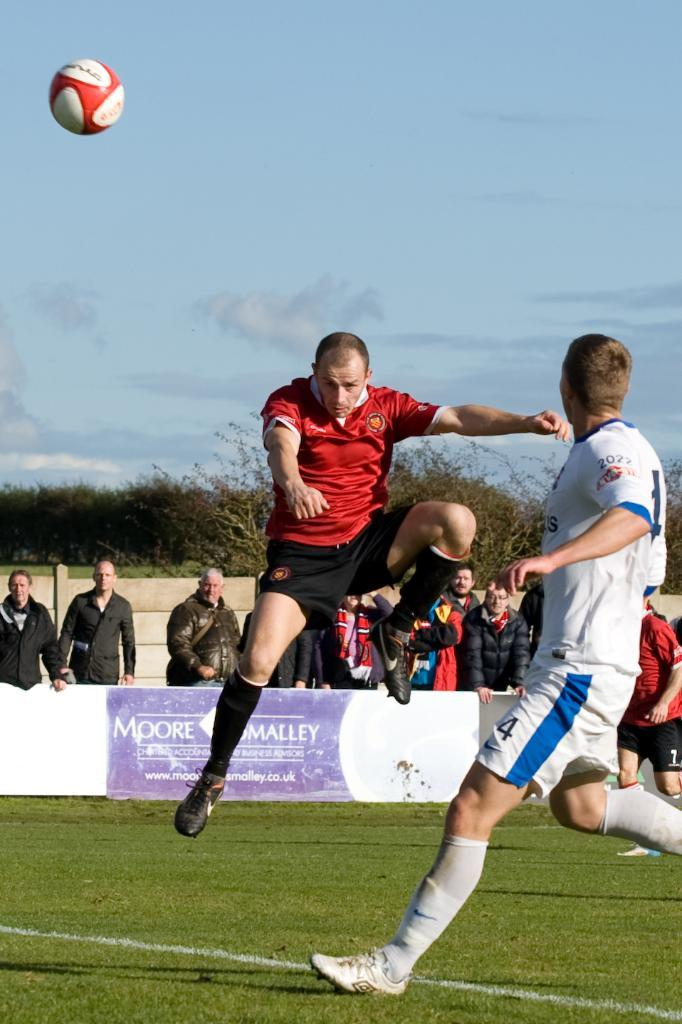<image>
Give a short and clear explanation of the subsequent image. Number 4 watches his opponent who has just struck the ball. 